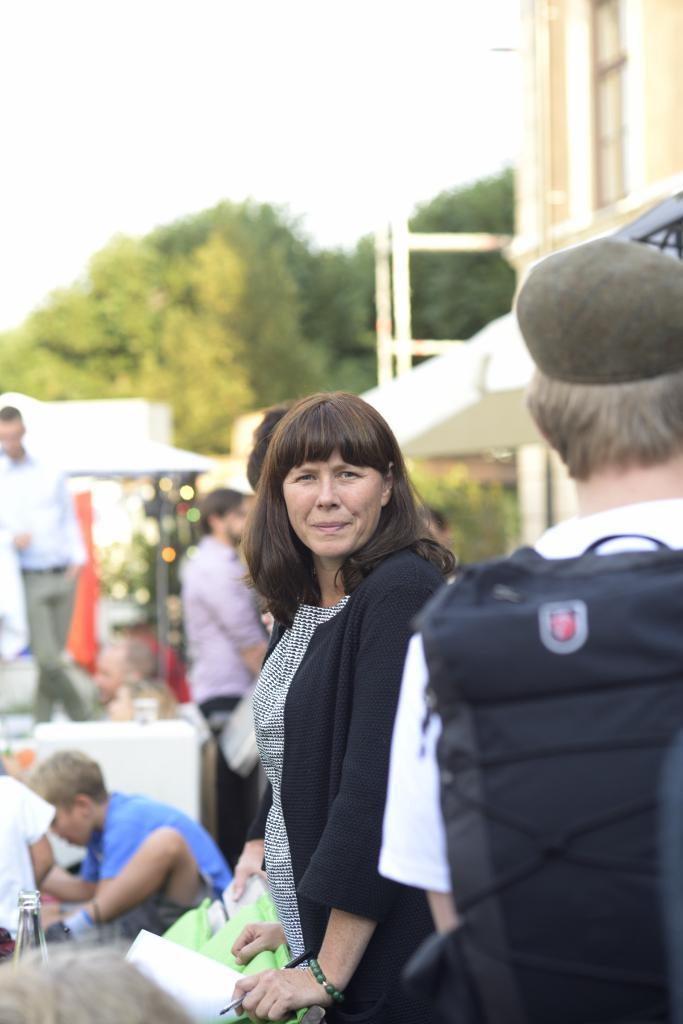How would you summarize this image in a sentence or two? This picture describes about group of people, on the right side of the image we can see a person, and the person wore a cap, in the background we can find a building and few trees. 